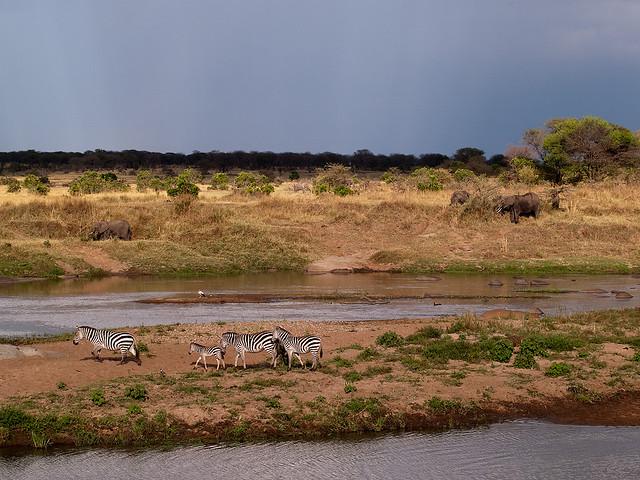Is this a "free range" space?
Write a very short answer. Yes. What other animal, besides zebras, can be seen?
Concise answer only. Elephant. What number of zebra are on this plane?
Keep it brief. 4. What kind of geological terrain is this?
Quick response, please. Savannah. 